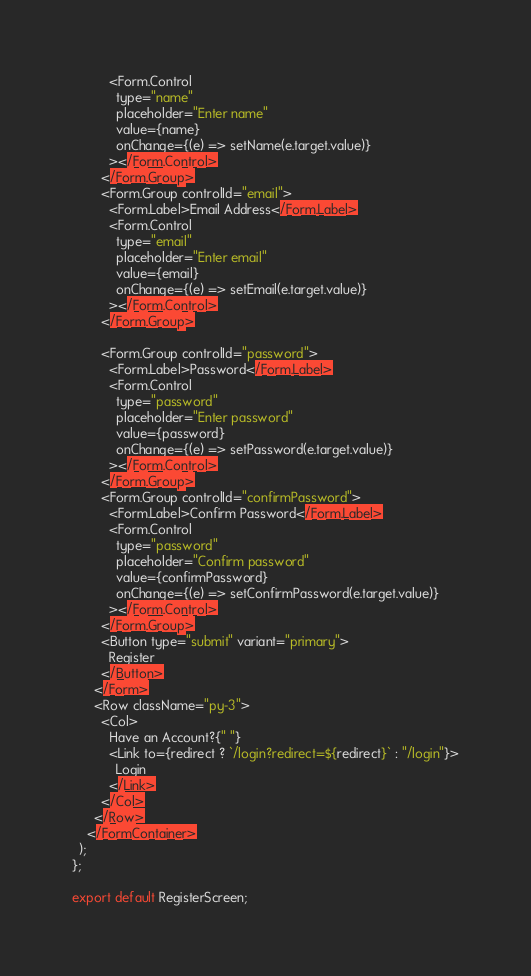Convert code to text. <code><loc_0><loc_0><loc_500><loc_500><_JavaScript_>          <Form.Control
            type="name"
            placeholder="Enter name"
            value={name}
            onChange={(e) => setName(e.target.value)}
          ></Form.Control>
        </Form.Group>
        <Form.Group controlId="email">
          <Form.Label>Email Address</Form.Label>
          <Form.Control
            type="email"
            placeholder="Enter email"
            value={email}
            onChange={(e) => setEmail(e.target.value)}
          ></Form.Control>
        </Form.Group>

        <Form.Group controlId="password">
          <Form.Label>Password</Form.Label>
          <Form.Control
            type="password"
            placeholder="Enter password"
            value={password}
            onChange={(e) => setPassword(e.target.value)}
          ></Form.Control>
        </Form.Group>
        <Form.Group controlId="confirmPassword">
          <Form.Label>Confirm Password</Form.Label>
          <Form.Control
            type="password"
            placeholder="Confirm password"
            value={confirmPassword}
            onChange={(e) => setConfirmPassword(e.target.value)}
          ></Form.Control>
        </Form.Group>
        <Button type="submit" variant="primary">
          Register
        </Button>
      </Form>
      <Row className="py-3">
        <Col>
          Have an Account?{" "}
          <Link to={redirect ? `/login?redirect=${redirect}` : "/login"}>
            Login
          </Link>
        </Col>
      </Row>
    </FormContainer>
  );
};

export default RegisterScreen;
</code> 